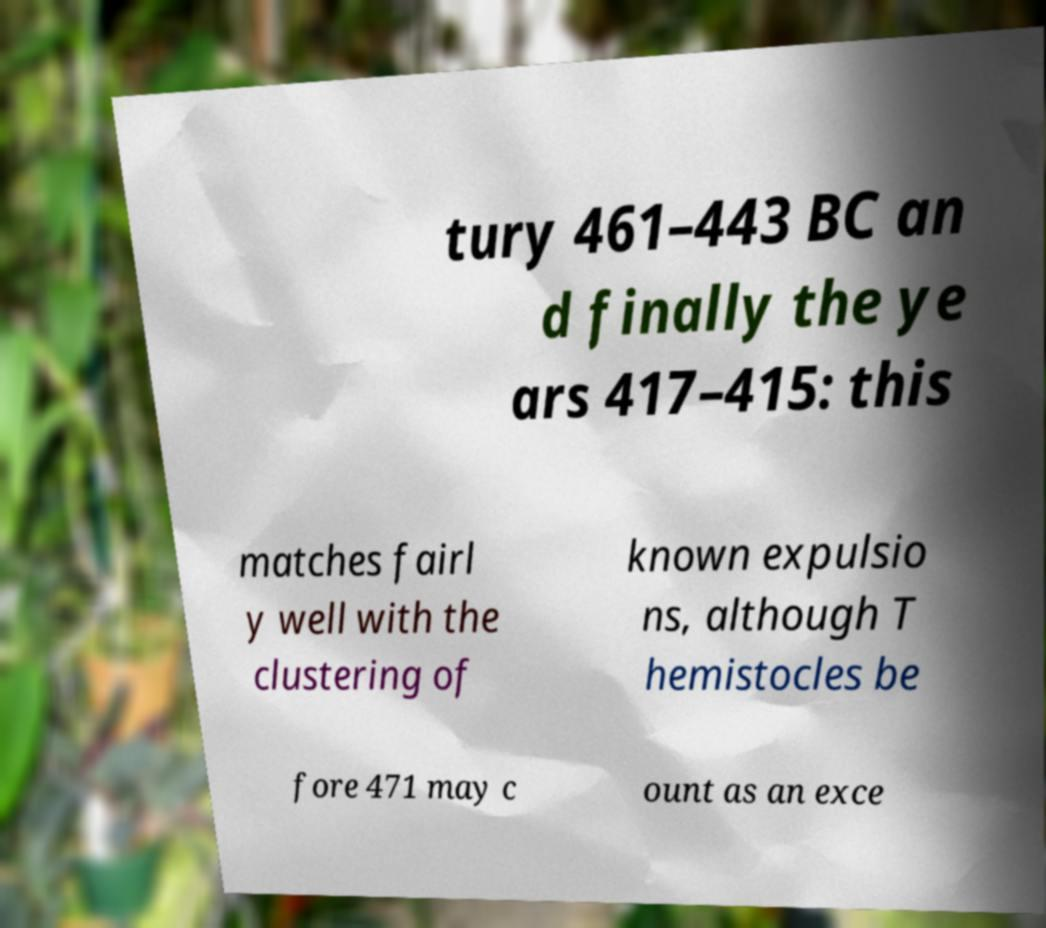There's text embedded in this image that I need extracted. Can you transcribe it verbatim? tury 461–443 BC an d finally the ye ars 417–415: this matches fairl y well with the clustering of known expulsio ns, although T hemistocles be fore 471 may c ount as an exce 